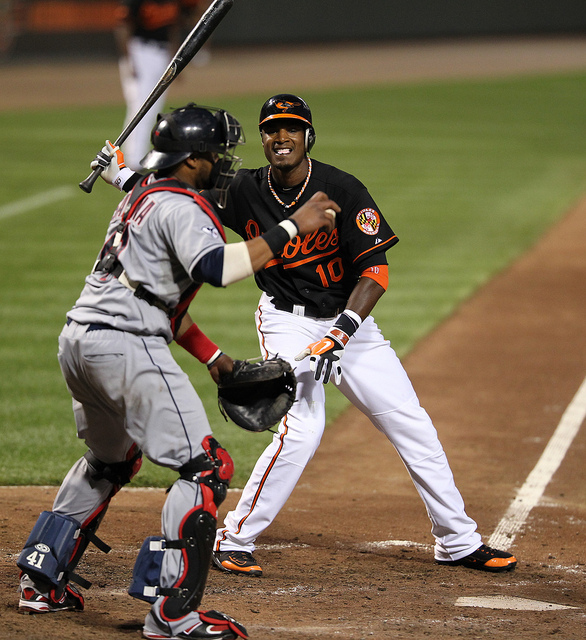Extract all visible text content from this image. olers 10 41 